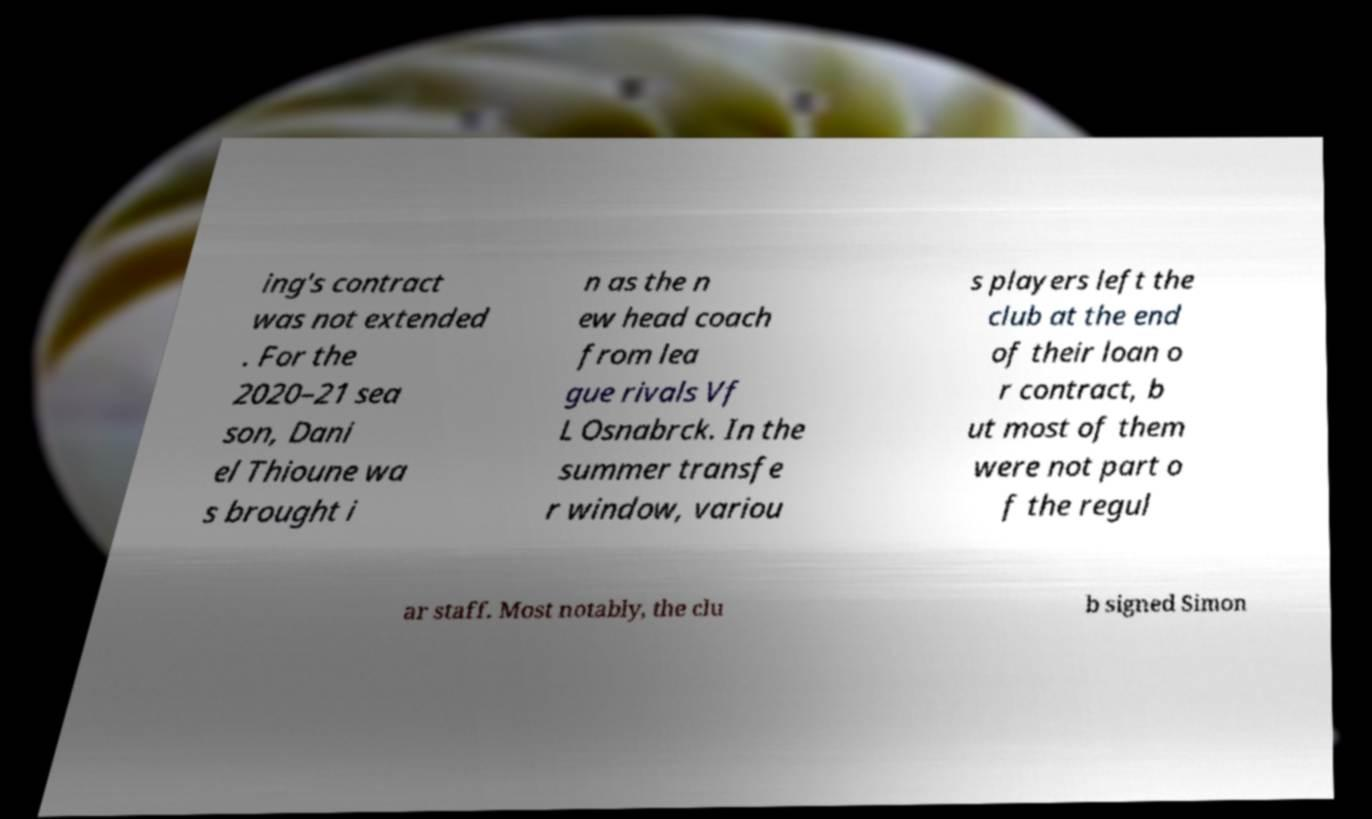Could you assist in decoding the text presented in this image and type it out clearly? ing's contract was not extended . For the 2020–21 sea son, Dani el Thioune wa s brought i n as the n ew head coach from lea gue rivals Vf L Osnabrck. In the summer transfe r window, variou s players left the club at the end of their loan o r contract, b ut most of them were not part o f the regul ar staff. Most notably, the clu b signed Simon 